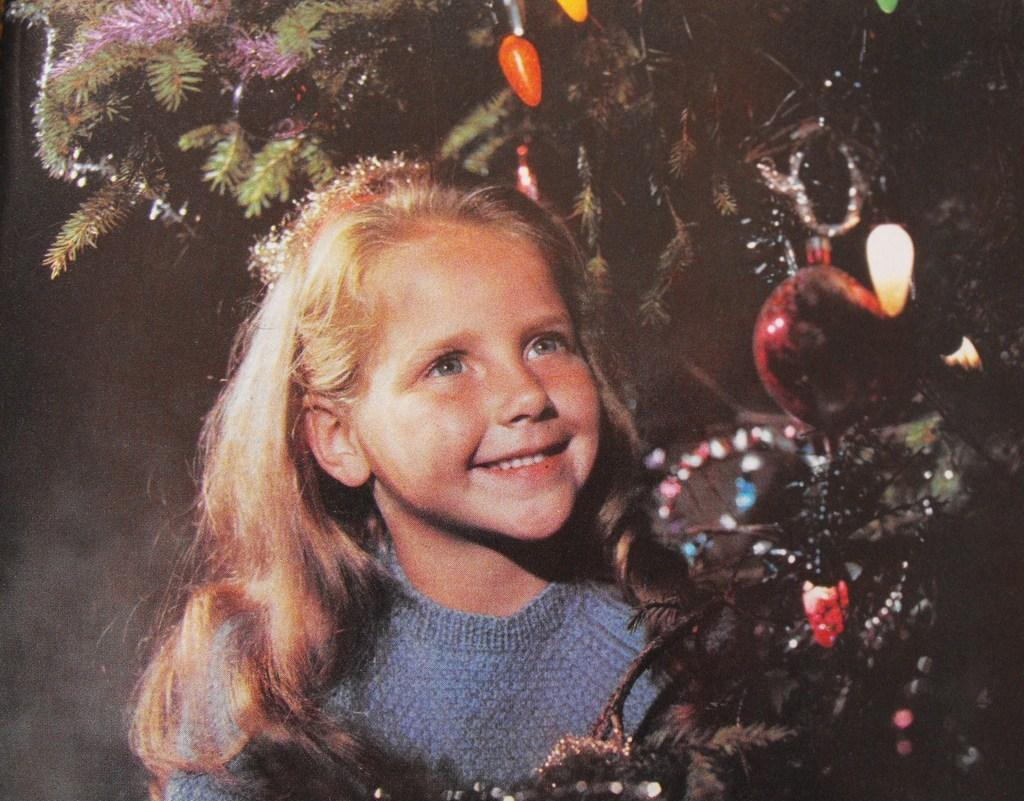Who is the main subject in the image? There is a girl in the image. What is the girl's expression in the image? The girl is smiling in the image. What can be seen in the background of the image? There is a tree in the image. What is on the tree in the image? There are objects on the tree in the image. What is the sister's reaction to the horse in the image? There is no sister or horse present in the image. 